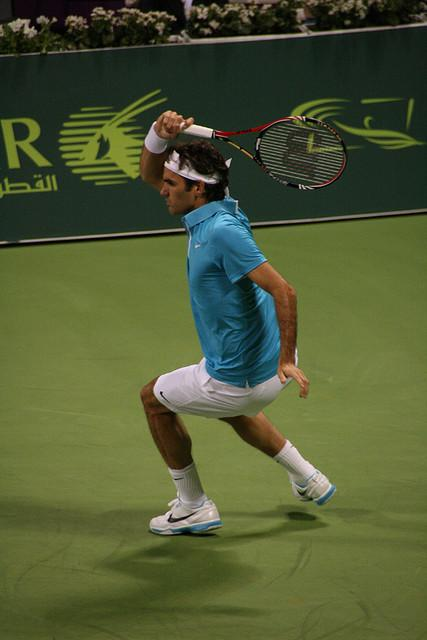What is the athletes last name? federer 